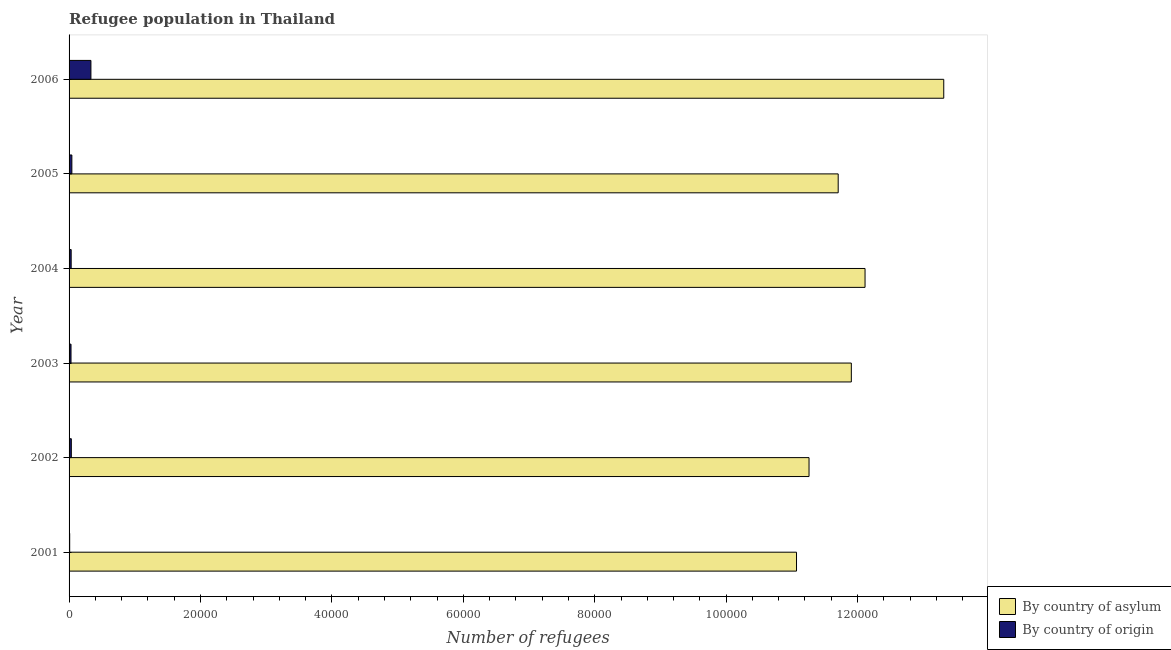How many different coloured bars are there?
Your answer should be compact. 2. Are the number of bars per tick equal to the number of legend labels?
Provide a succinct answer. Yes. Are the number of bars on each tick of the Y-axis equal?
Ensure brevity in your answer.  Yes. How many bars are there on the 2nd tick from the bottom?
Make the answer very short. 2. In how many cases, is the number of bars for a given year not equal to the number of legend labels?
Your response must be concise. 0. What is the number of refugees by country of asylum in 2001?
Keep it short and to the point. 1.11e+05. Across all years, what is the maximum number of refugees by country of asylum?
Ensure brevity in your answer.  1.33e+05. Across all years, what is the minimum number of refugees by country of origin?
Ensure brevity in your answer.  94. In which year was the number of refugees by country of origin minimum?
Give a very brief answer. 2001. What is the total number of refugees by country of asylum in the graph?
Provide a short and direct response. 7.14e+05. What is the difference between the number of refugees by country of origin in 2004 and that in 2005?
Make the answer very short. -105. What is the difference between the number of refugees by country of asylum in 2002 and the number of refugees by country of origin in 2001?
Ensure brevity in your answer.  1.13e+05. What is the average number of refugees by country of origin per year?
Offer a very short reply. 800.33. In the year 2004, what is the difference between the number of refugees by country of origin and number of refugees by country of asylum?
Your answer should be compact. -1.21e+05. What is the ratio of the number of refugees by country of asylum in 2002 to that in 2003?
Your response must be concise. 0.95. Is the difference between the number of refugees by country of origin in 2001 and 2005 greater than the difference between the number of refugees by country of asylum in 2001 and 2005?
Make the answer very short. Yes. What is the difference between the highest and the second highest number of refugees by country of asylum?
Give a very brief answer. 1.20e+04. What is the difference between the highest and the lowest number of refugees by country of origin?
Your answer should be compact. 3231. What does the 2nd bar from the top in 2002 represents?
Give a very brief answer. By country of asylum. What does the 2nd bar from the bottom in 2003 represents?
Your answer should be compact. By country of origin. How many bars are there?
Give a very brief answer. 12. Are all the bars in the graph horizontal?
Make the answer very short. Yes. What is the difference between two consecutive major ticks on the X-axis?
Provide a succinct answer. 2.00e+04. Does the graph contain any zero values?
Offer a terse response. No. Where does the legend appear in the graph?
Offer a terse response. Bottom right. How many legend labels are there?
Ensure brevity in your answer.  2. What is the title of the graph?
Offer a terse response. Refugee population in Thailand. Does "From human activities" appear as one of the legend labels in the graph?
Give a very brief answer. No. What is the label or title of the X-axis?
Make the answer very short. Number of refugees. What is the label or title of the Y-axis?
Keep it short and to the point. Year. What is the Number of refugees in By country of asylum in 2001?
Provide a short and direct response. 1.11e+05. What is the Number of refugees in By country of origin in 2001?
Your response must be concise. 94. What is the Number of refugees of By country of asylum in 2002?
Make the answer very short. 1.13e+05. What is the Number of refugees of By country of origin in 2002?
Your response must be concise. 344. What is the Number of refugees in By country of asylum in 2003?
Give a very brief answer. 1.19e+05. What is the Number of refugees of By country of origin in 2003?
Offer a terse response. 296. What is the Number of refugees of By country of asylum in 2004?
Offer a terse response. 1.21e+05. What is the Number of refugees in By country of origin in 2004?
Keep it short and to the point. 319. What is the Number of refugees of By country of asylum in 2005?
Provide a succinct answer. 1.17e+05. What is the Number of refugees of By country of origin in 2005?
Your answer should be compact. 424. What is the Number of refugees of By country of asylum in 2006?
Make the answer very short. 1.33e+05. What is the Number of refugees in By country of origin in 2006?
Provide a succinct answer. 3325. Across all years, what is the maximum Number of refugees in By country of asylum?
Ensure brevity in your answer.  1.33e+05. Across all years, what is the maximum Number of refugees in By country of origin?
Give a very brief answer. 3325. Across all years, what is the minimum Number of refugees of By country of asylum?
Give a very brief answer. 1.11e+05. Across all years, what is the minimum Number of refugees of By country of origin?
Ensure brevity in your answer.  94. What is the total Number of refugees of By country of asylum in the graph?
Provide a succinct answer. 7.14e+05. What is the total Number of refugees of By country of origin in the graph?
Offer a terse response. 4802. What is the difference between the Number of refugees of By country of asylum in 2001 and that in 2002?
Provide a succinct answer. -1903. What is the difference between the Number of refugees of By country of origin in 2001 and that in 2002?
Offer a very short reply. -250. What is the difference between the Number of refugees of By country of asylum in 2001 and that in 2003?
Make the answer very short. -8342. What is the difference between the Number of refugees of By country of origin in 2001 and that in 2003?
Your answer should be very brief. -202. What is the difference between the Number of refugees of By country of asylum in 2001 and that in 2004?
Provide a short and direct response. -1.04e+04. What is the difference between the Number of refugees in By country of origin in 2001 and that in 2004?
Your answer should be compact. -225. What is the difference between the Number of refugees in By country of asylum in 2001 and that in 2005?
Provide a short and direct response. -6342. What is the difference between the Number of refugees of By country of origin in 2001 and that in 2005?
Offer a terse response. -330. What is the difference between the Number of refugees of By country of asylum in 2001 and that in 2006?
Ensure brevity in your answer.  -2.24e+04. What is the difference between the Number of refugees in By country of origin in 2001 and that in 2006?
Your response must be concise. -3231. What is the difference between the Number of refugees of By country of asylum in 2002 and that in 2003?
Offer a very short reply. -6439. What is the difference between the Number of refugees in By country of asylum in 2002 and that in 2004?
Make the answer very short. -8525. What is the difference between the Number of refugees in By country of asylum in 2002 and that in 2005?
Your response must be concise. -4439. What is the difference between the Number of refugees of By country of origin in 2002 and that in 2005?
Offer a terse response. -80. What is the difference between the Number of refugees of By country of asylum in 2002 and that in 2006?
Offer a very short reply. -2.05e+04. What is the difference between the Number of refugees of By country of origin in 2002 and that in 2006?
Provide a short and direct response. -2981. What is the difference between the Number of refugees in By country of asylum in 2003 and that in 2004?
Provide a succinct answer. -2086. What is the difference between the Number of refugees in By country of origin in 2003 and that in 2005?
Your answer should be compact. -128. What is the difference between the Number of refugees of By country of asylum in 2003 and that in 2006?
Offer a terse response. -1.41e+04. What is the difference between the Number of refugees in By country of origin in 2003 and that in 2006?
Make the answer very short. -3029. What is the difference between the Number of refugees in By country of asylum in 2004 and that in 2005?
Offer a terse response. 4086. What is the difference between the Number of refugees in By country of origin in 2004 and that in 2005?
Offer a terse response. -105. What is the difference between the Number of refugees in By country of asylum in 2004 and that in 2006?
Offer a terse response. -1.20e+04. What is the difference between the Number of refugees of By country of origin in 2004 and that in 2006?
Provide a short and direct response. -3006. What is the difference between the Number of refugees in By country of asylum in 2005 and that in 2006?
Give a very brief answer. -1.61e+04. What is the difference between the Number of refugees in By country of origin in 2005 and that in 2006?
Make the answer very short. -2901. What is the difference between the Number of refugees of By country of asylum in 2001 and the Number of refugees of By country of origin in 2002?
Your answer should be very brief. 1.10e+05. What is the difference between the Number of refugees of By country of asylum in 2001 and the Number of refugees of By country of origin in 2003?
Keep it short and to the point. 1.10e+05. What is the difference between the Number of refugees in By country of asylum in 2001 and the Number of refugees in By country of origin in 2004?
Ensure brevity in your answer.  1.10e+05. What is the difference between the Number of refugees in By country of asylum in 2001 and the Number of refugees in By country of origin in 2005?
Keep it short and to the point. 1.10e+05. What is the difference between the Number of refugees of By country of asylum in 2001 and the Number of refugees of By country of origin in 2006?
Your answer should be compact. 1.07e+05. What is the difference between the Number of refugees in By country of asylum in 2002 and the Number of refugees in By country of origin in 2003?
Provide a short and direct response. 1.12e+05. What is the difference between the Number of refugees in By country of asylum in 2002 and the Number of refugees in By country of origin in 2004?
Your answer should be compact. 1.12e+05. What is the difference between the Number of refugees in By country of asylum in 2002 and the Number of refugees in By country of origin in 2005?
Keep it short and to the point. 1.12e+05. What is the difference between the Number of refugees in By country of asylum in 2002 and the Number of refugees in By country of origin in 2006?
Ensure brevity in your answer.  1.09e+05. What is the difference between the Number of refugees of By country of asylum in 2003 and the Number of refugees of By country of origin in 2004?
Your answer should be compact. 1.19e+05. What is the difference between the Number of refugees in By country of asylum in 2003 and the Number of refugees in By country of origin in 2005?
Your response must be concise. 1.19e+05. What is the difference between the Number of refugees in By country of asylum in 2003 and the Number of refugees in By country of origin in 2006?
Provide a short and direct response. 1.16e+05. What is the difference between the Number of refugees in By country of asylum in 2004 and the Number of refugees in By country of origin in 2005?
Offer a very short reply. 1.21e+05. What is the difference between the Number of refugees of By country of asylum in 2004 and the Number of refugees of By country of origin in 2006?
Ensure brevity in your answer.  1.18e+05. What is the difference between the Number of refugees in By country of asylum in 2005 and the Number of refugees in By country of origin in 2006?
Ensure brevity in your answer.  1.14e+05. What is the average Number of refugees in By country of asylum per year?
Make the answer very short. 1.19e+05. What is the average Number of refugees of By country of origin per year?
Keep it short and to the point. 800.33. In the year 2001, what is the difference between the Number of refugees of By country of asylum and Number of refugees of By country of origin?
Your answer should be compact. 1.11e+05. In the year 2002, what is the difference between the Number of refugees of By country of asylum and Number of refugees of By country of origin?
Give a very brief answer. 1.12e+05. In the year 2003, what is the difference between the Number of refugees of By country of asylum and Number of refugees of By country of origin?
Ensure brevity in your answer.  1.19e+05. In the year 2004, what is the difference between the Number of refugees in By country of asylum and Number of refugees in By country of origin?
Provide a short and direct response. 1.21e+05. In the year 2005, what is the difference between the Number of refugees in By country of asylum and Number of refugees in By country of origin?
Keep it short and to the point. 1.17e+05. In the year 2006, what is the difference between the Number of refugees in By country of asylum and Number of refugees in By country of origin?
Give a very brief answer. 1.30e+05. What is the ratio of the Number of refugees of By country of asylum in 2001 to that in 2002?
Give a very brief answer. 0.98. What is the ratio of the Number of refugees of By country of origin in 2001 to that in 2002?
Keep it short and to the point. 0.27. What is the ratio of the Number of refugees of By country of asylum in 2001 to that in 2003?
Your response must be concise. 0.93. What is the ratio of the Number of refugees of By country of origin in 2001 to that in 2003?
Keep it short and to the point. 0.32. What is the ratio of the Number of refugees of By country of asylum in 2001 to that in 2004?
Provide a short and direct response. 0.91. What is the ratio of the Number of refugees of By country of origin in 2001 to that in 2004?
Make the answer very short. 0.29. What is the ratio of the Number of refugees in By country of asylum in 2001 to that in 2005?
Offer a very short reply. 0.95. What is the ratio of the Number of refugees of By country of origin in 2001 to that in 2005?
Make the answer very short. 0.22. What is the ratio of the Number of refugees of By country of asylum in 2001 to that in 2006?
Provide a short and direct response. 0.83. What is the ratio of the Number of refugees in By country of origin in 2001 to that in 2006?
Your response must be concise. 0.03. What is the ratio of the Number of refugees in By country of asylum in 2002 to that in 2003?
Provide a short and direct response. 0.95. What is the ratio of the Number of refugees of By country of origin in 2002 to that in 2003?
Provide a short and direct response. 1.16. What is the ratio of the Number of refugees in By country of asylum in 2002 to that in 2004?
Your answer should be very brief. 0.93. What is the ratio of the Number of refugees in By country of origin in 2002 to that in 2004?
Keep it short and to the point. 1.08. What is the ratio of the Number of refugees in By country of asylum in 2002 to that in 2005?
Your answer should be compact. 0.96. What is the ratio of the Number of refugees in By country of origin in 2002 to that in 2005?
Offer a very short reply. 0.81. What is the ratio of the Number of refugees of By country of asylum in 2002 to that in 2006?
Offer a very short reply. 0.85. What is the ratio of the Number of refugees in By country of origin in 2002 to that in 2006?
Offer a very short reply. 0.1. What is the ratio of the Number of refugees of By country of asylum in 2003 to that in 2004?
Provide a succinct answer. 0.98. What is the ratio of the Number of refugees in By country of origin in 2003 to that in 2004?
Ensure brevity in your answer.  0.93. What is the ratio of the Number of refugees in By country of asylum in 2003 to that in 2005?
Offer a very short reply. 1.02. What is the ratio of the Number of refugees in By country of origin in 2003 to that in 2005?
Ensure brevity in your answer.  0.7. What is the ratio of the Number of refugees in By country of asylum in 2003 to that in 2006?
Offer a very short reply. 0.89. What is the ratio of the Number of refugees of By country of origin in 2003 to that in 2006?
Keep it short and to the point. 0.09. What is the ratio of the Number of refugees of By country of asylum in 2004 to that in 2005?
Give a very brief answer. 1.03. What is the ratio of the Number of refugees of By country of origin in 2004 to that in 2005?
Offer a terse response. 0.75. What is the ratio of the Number of refugees in By country of asylum in 2004 to that in 2006?
Your response must be concise. 0.91. What is the ratio of the Number of refugees of By country of origin in 2004 to that in 2006?
Make the answer very short. 0.1. What is the ratio of the Number of refugees of By country of asylum in 2005 to that in 2006?
Your answer should be very brief. 0.88. What is the ratio of the Number of refugees of By country of origin in 2005 to that in 2006?
Your answer should be very brief. 0.13. What is the difference between the highest and the second highest Number of refugees of By country of asylum?
Offer a terse response. 1.20e+04. What is the difference between the highest and the second highest Number of refugees of By country of origin?
Offer a terse response. 2901. What is the difference between the highest and the lowest Number of refugees of By country of asylum?
Keep it short and to the point. 2.24e+04. What is the difference between the highest and the lowest Number of refugees of By country of origin?
Provide a succinct answer. 3231. 